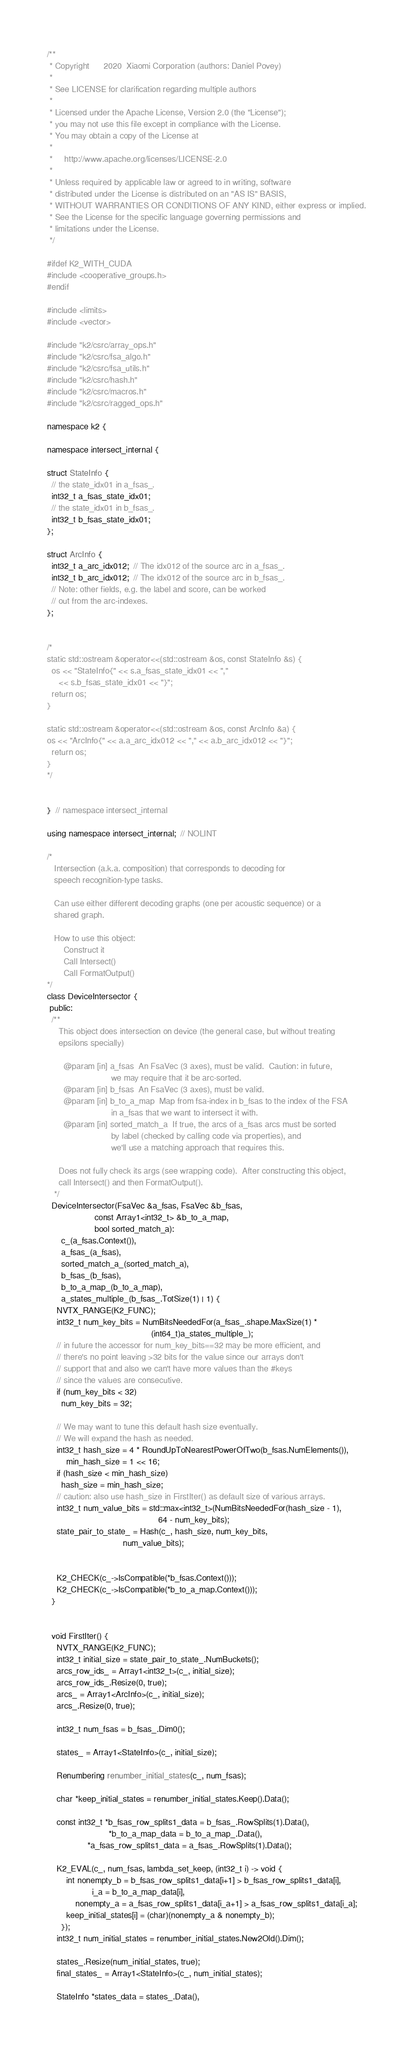Convert code to text. <code><loc_0><loc_0><loc_500><loc_500><_Cuda_>/**
 * Copyright      2020  Xiaomi Corporation (authors: Daniel Povey)
 *
 * See LICENSE for clarification regarding multiple authors
 *
 * Licensed under the Apache License, Version 2.0 (the "License");
 * you may not use this file except in compliance with the License.
 * You may obtain a copy of the License at
 *
 *     http://www.apache.org/licenses/LICENSE-2.0
 *
 * Unless required by applicable law or agreed to in writing, software
 * distributed under the License is distributed on an "AS IS" BASIS,
 * WITHOUT WARRANTIES OR CONDITIONS OF ANY KIND, either express or implied.
 * See the License for the specific language governing permissions and
 * limitations under the License.
 */

#ifdef K2_WITH_CUDA
#include <cooperative_groups.h>
#endif

#include <limits>
#include <vector>

#include "k2/csrc/array_ops.h"
#include "k2/csrc/fsa_algo.h"
#include "k2/csrc/fsa_utils.h"
#include "k2/csrc/hash.h"
#include "k2/csrc/macros.h"
#include "k2/csrc/ragged_ops.h"

namespace k2 {

namespace intersect_internal {

struct StateInfo {
  // the state_idx01 in a_fsas_.
  int32_t a_fsas_state_idx01;
  // the state_idx01 in b_fsas_.
  int32_t b_fsas_state_idx01;
};

struct ArcInfo {
  int32_t a_arc_idx012;  // The idx012 of the source arc in a_fsas_.
  int32_t b_arc_idx012;  // The idx012 of the source arc in b_fsas_.
  // Note: other fields, e.g. the label and score, can be worked
  // out from the arc-indexes.
};


/*
static std::ostream &operator<<(std::ostream &os, const StateInfo &s) {
  os << "StateInfo{" << s.a_fsas_state_idx01 << ","
     << s.b_fsas_state_idx01 << "}";
  return os;
}

static std::ostream &operator<<(std::ostream &os, const ArcInfo &a) {
os << "ArcInfo{" << a.a_arc_idx012 << "," << a.b_arc_idx012 << "}";
  return os;
}
*/


}  // namespace intersect_internal

using namespace intersect_internal;  // NOLINT

/*
   Intersection (a.k.a. composition) that corresponds to decoding for
   speech recognition-type tasks.

   Can use either different decoding graphs (one per acoustic sequence) or a
   shared graph.

   How to use this object:
       Construct it
       Call Intersect()
       Call FormatOutput()
*/
class DeviceIntersector {
 public:
  /**
     This object does intersection on device (the general case, but without treating
     epsilons specially)

       @param [in] a_fsas  An FsaVec (3 axes), must be valid.  Caution: in future,
                           we may require that it be arc-sorted.
       @param [in] b_fsas  An FsaVec (3 axes), must be valid.
       @param [in] b_to_a_map  Map from fsa-index in b_fsas to the index of the FSA
                           in a_fsas that we want to intersect it with.
       @param [in] sorted_match_a  If true, the arcs of a_fsas arcs must be sorted
                           by label (checked by calling code via properties), and
                           we'll use a matching approach that requires this.

     Does not fully check its args (see wrapping code).  After constructing this object,
     call Intersect() and then FormatOutput().
   */
  DeviceIntersector(FsaVec &a_fsas, FsaVec &b_fsas,
                    const Array1<int32_t> &b_to_a_map,
                    bool sorted_match_a):
      c_(a_fsas.Context()),
      a_fsas_(a_fsas),
      sorted_match_a_(sorted_match_a),
      b_fsas_(b_fsas),
      b_to_a_map_(b_to_a_map),
      a_states_multiple_(b_fsas_.TotSize(1) | 1) {
    NVTX_RANGE(K2_FUNC);
    int32_t num_key_bits = NumBitsNeededFor(a_fsas_.shape.MaxSize(1) *
                                            (int64_t)a_states_multiple_);
    // in future the accessor for num_key_bits==32 may be more efficient, and
    // there's no point leaving >32 bits for the value since our arrays don't
    // support that and also we can't have more values than the #keys
    // since the values are consecutive.
    if (num_key_bits < 32)
      num_key_bits = 32;

    // We may want to tune this default hash size eventually.
    // We will expand the hash as needed.
    int32_t hash_size = 4 * RoundUpToNearestPowerOfTwo(b_fsas.NumElements()),
        min_hash_size = 1 << 16;
    if (hash_size < min_hash_size)
      hash_size = min_hash_size;
    // caution: also use hash_size in FirstIter() as default size of various arrays.
    int32_t num_value_bits = std::max<int32_t>(NumBitsNeededFor(hash_size - 1),
                                               64 - num_key_bits);
    state_pair_to_state_ = Hash(c_, hash_size, num_key_bits,
                                num_value_bits);


    K2_CHECK(c_->IsCompatible(*b_fsas.Context()));
    K2_CHECK(c_->IsCompatible(*b_to_a_map.Context()));
  }


  void FirstIter() {
    NVTX_RANGE(K2_FUNC);
    int32_t initial_size = state_pair_to_state_.NumBuckets();
    arcs_row_ids_ = Array1<int32_t>(c_, initial_size);
    arcs_row_ids_.Resize(0, true);
    arcs_ = Array1<ArcInfo>(c_, initial_size);
    arcs_.Resize(0, true);

    int32_t num_fsas = b_fsas_.Dim0();

    states_ = Array1<StateInfo>(c_, initial_size);

    Renumbering renumber_initial_states(c_, num_fsas);

    char *keep_initial_states = renumber_initial_states.Keep().Data();

    const int32_t *b_fsas_row_splits1_data = b_fsas_.RowSplits(1).Data(),
                          *b_to_a_map_data = b_to_a_map_.Data(),
                 *a_fsas_row_splits1_data = a_fsas_.RowSplits(1).Data();

    K2_EVAL(c_, num_fsas, lambda_set_keep, (int32_t i) -> void {
        int nonempty_b = b_fsas_row_splits1_data[i+1] > b_fsas_row_splits1_data[i],
                   i_a = b_to_a_map_data[i],
            nonempty_a = a_fsas_row_splits1_data[i_a+1] > a_fsas_row_splits1_data[i_a];
        keep_initial_states[i] = (char)(nonempty_a & nonempty_b);
      });
    int32_t num_initial_states = renumber_initial_states.New2Old().Dim();

    states_.Resize(num_initial_states, true);
    final_states_ = Array1<StateInfo>(c_, num_initial_states);

    StateInfo *states_data = states_.Data(),</code> 